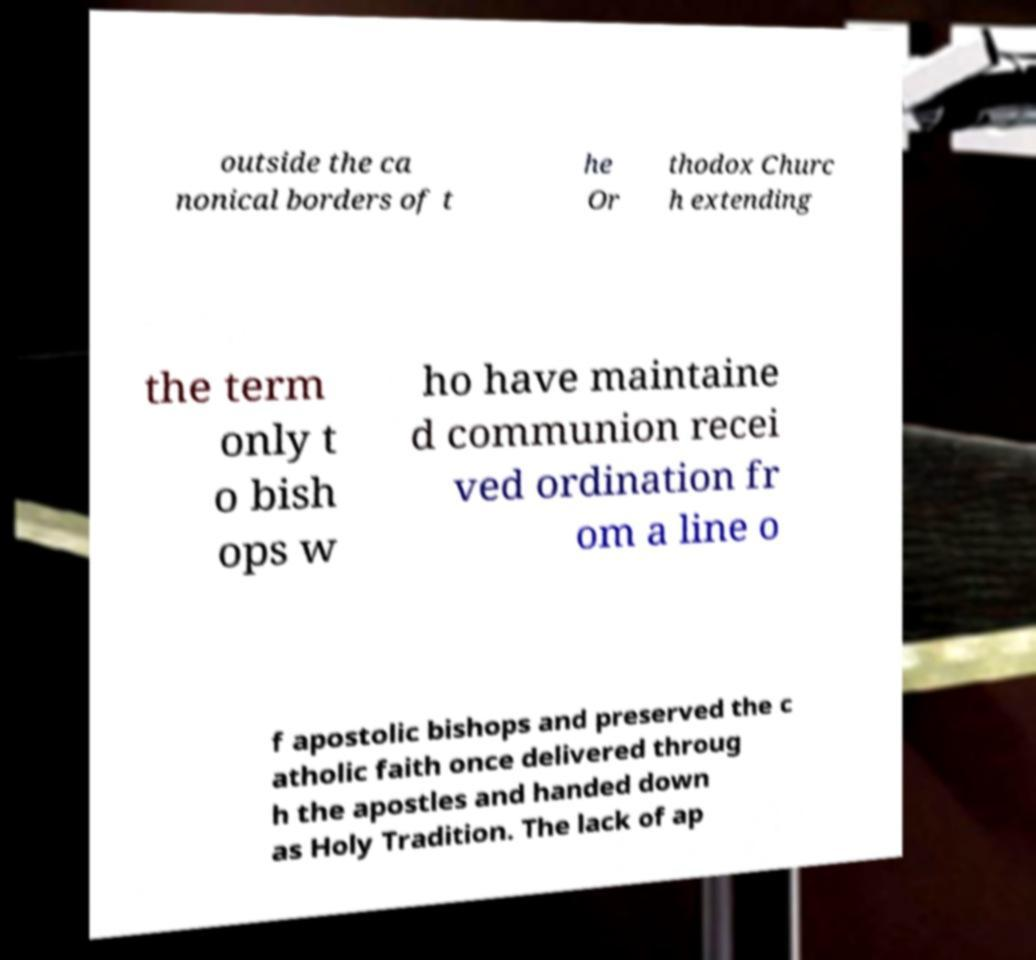Please read and relay the text visible in this image. What does it say? outside the ca nonical borders of t he Or thodox Churc h extending the term only t o bish ops w ho have maintaine d communion recei ved ordination fr om a line o f apostolic bishops and preserved the c atholic faith once delivered throug h the apostles and handed down as Holy Tradition. The lack of ap 